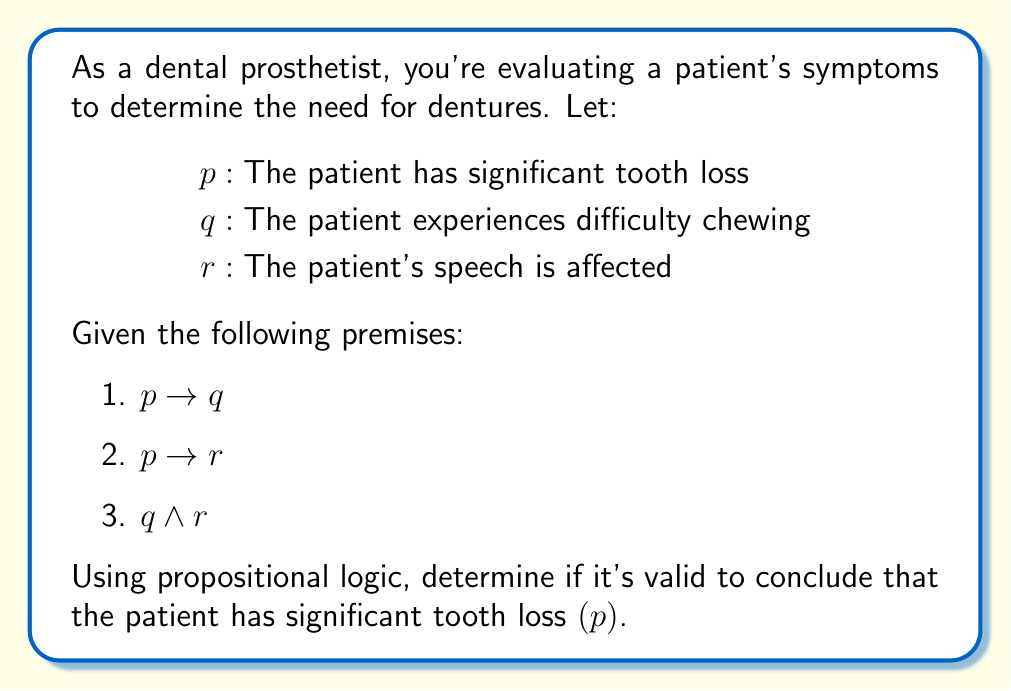Can you solve this math problem? Let's approach this step-by-step using propositional logic:

1) We're given three premises:
   $p \rightarrow q$ (If there's significant tooth loss, then there's difficulty chewing)
   $p \rightarrow r$ (If there's significant tooth loss, then speech is affected)
   $q \land r$ (The patient has difficulty chewing AND speech is affected)

2) We want to determine if $p$ (significant tooth loss) can be validly concluded.

3) Let's use the method of proof by contradiction. We'll assume $\neg p$ (not $p$) and see if it leads to a contradiction with our premises.

4) If $\neg p$ is true, then from premises 1 and 2, we can't conclude anything about $q$ or $r$. The implications $p \rightarrow q$ and $p \rightarrow r$ don't tell us anything when $p$ is false.

5) However, we know from premise 3 that $q \land r$ is true.

6) This doesn't contradict our assumption of $\neg p$. It's possible for a patient to have difficulty chewing and affected speech without significant tooth loss (there could be other causes).

7) Since assuming $\neg p$ doesn't lead to a contradiction, we can't validly conclude $p$.

In propositional logic, this is an example of the fallacy of affirming the consequent. Just because the consequents ($q$ and $r$) are true, we can't necessarily conclude that the antecedent ($p$) is true.
Answer: No, it's not valid to conclude that the patient has significant tooth loss $(p)$ based on the given premises. 